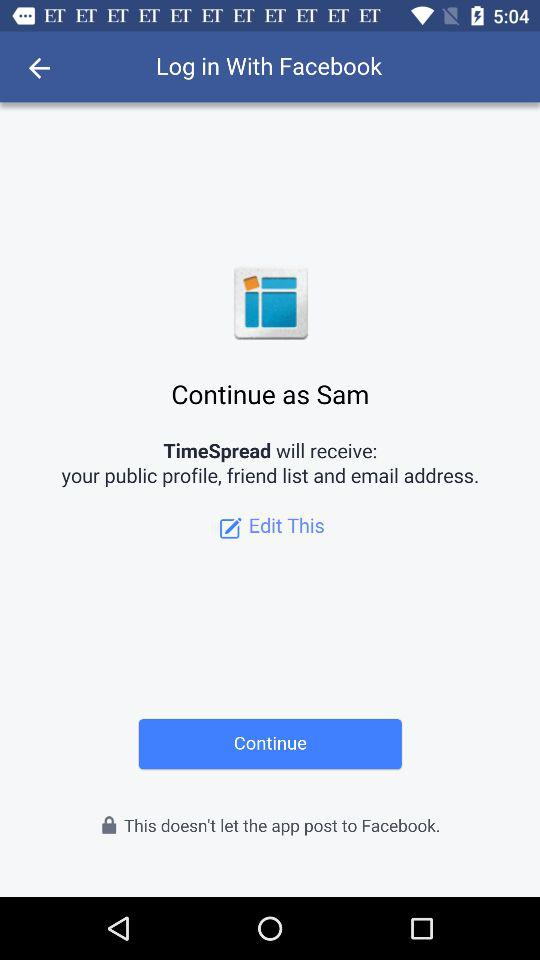What is the name of the user through whom the application can be continued? The name of the user through whom the application can be continued is Sam. 